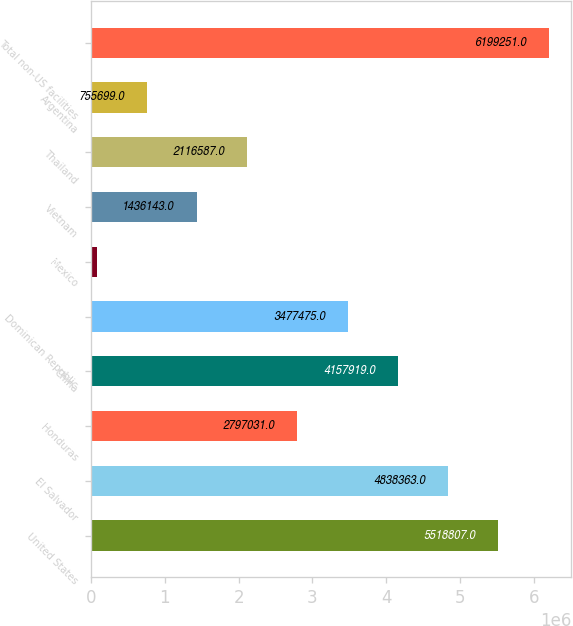Convert chart. <chart><loc_0><loc_0><loc_500><loc_500><bar_chart><fcel>United States<fcel>El Salvador<fcel>Honduras<fcel>China<fcel>Dominican Republic<fcel>Mexico<fcel>Vietnam<fcel>Thailand<fcel>Argentina<fcel>Total non-US facilities<nl><fcel>5.51881e+06<fcel>4.83836e+06<fcel>2.79703e+06<fcel>4.15792e+06<fcel>3.47748e+06<fcel>75255<fcel>1.43614e+06<fcel>2.11659e+06<fcel>755699<fcel>6.19925e+06<nl></chart> 